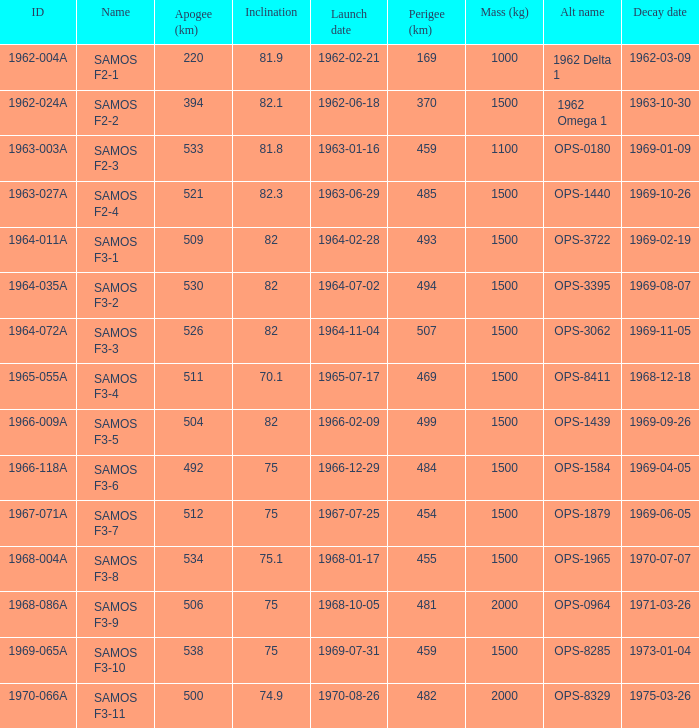What is the maximum apogee for samos f3-3? 526.0. 